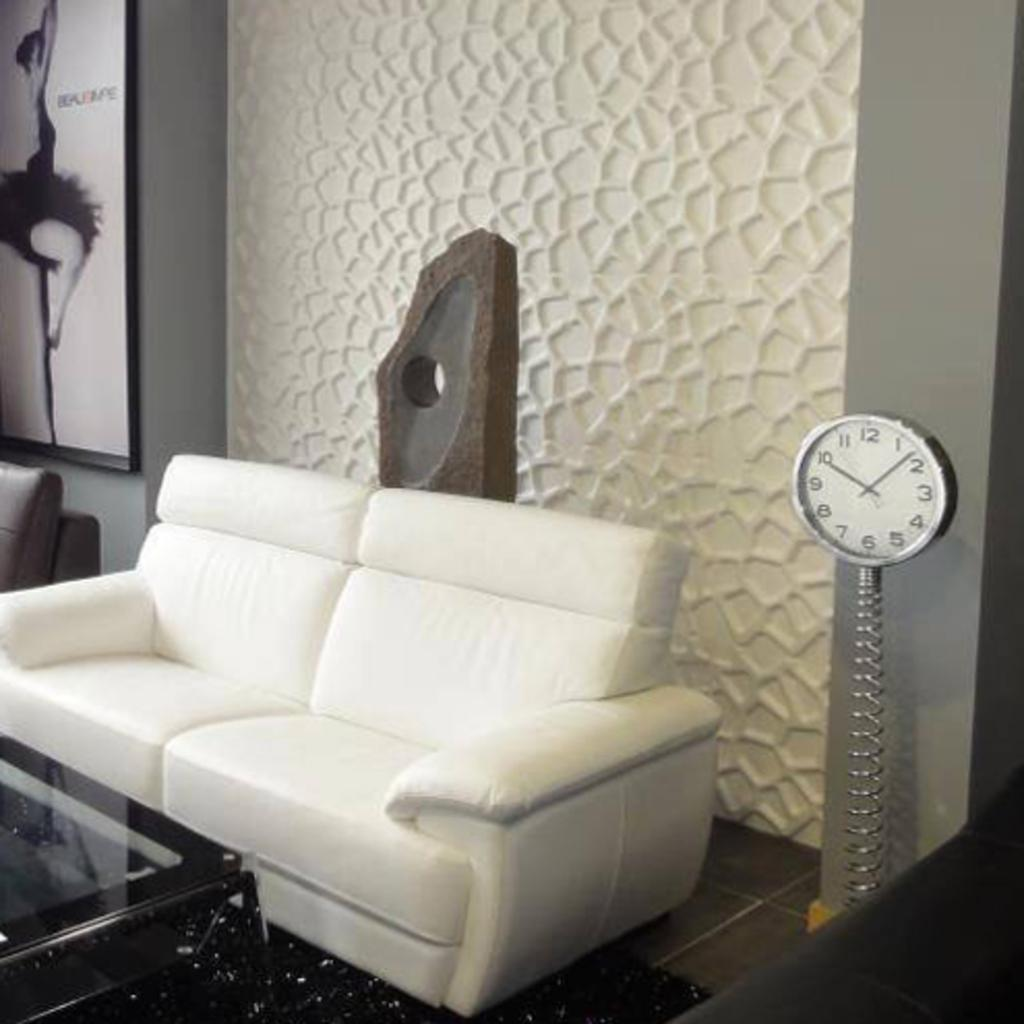What is the color of the wall in the image? The wall in the image is white. What can be seen hanging on the wall? There is a photo frame in the image. What type of furniture is present in the image? There is a sofa in the image. What time-related object is visible in the image? There is a clock in the image. How many sisters are sitting on the sofa in the image? There is no mention of a sister or any people in the image; it only features a white wall, a photo frame, a sofa, and a clock. 